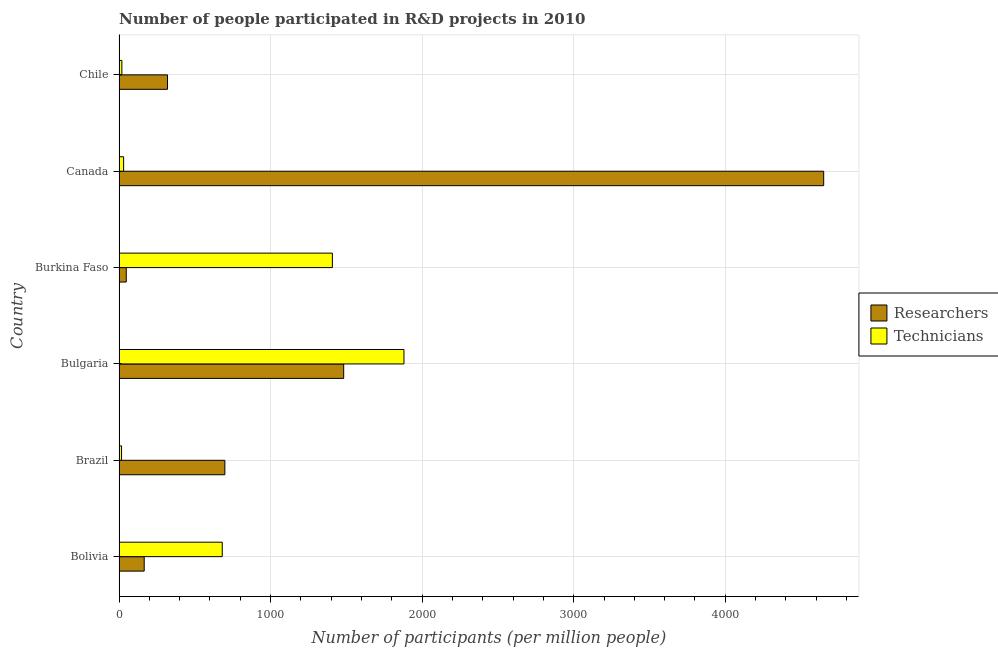How many different coloured bars are there?
Provide a succinct answer. 2. How many groups of bars are there?
Keep it short and to the point. 6. Are the number of bars on each tick of the Y-axis equal?
Offer a very short reply. Yes. How many bars are there on the 1st tick from the top?
Your answer should be compact. 2. How many bars are there on the 1st tick from the bottom?
Ensure brevity in your answer.  2. What is the label of the 4th group of bars from the top?
Provide a succinct answer. Bulgaria. In how many cases, is the number of bars for a given country not equal to the number of legend labels?
Your answer should be very brief. 0. What is the number of researchers in Chile?
Your answer should be compact. 319.72. Across all countries, what is the maximum number of researchers?
Give a very brief answer. 4649.22. Across all countries, what is the minimum number of technicians?
Ensure brevity in your answer.  16.46. In which country was the number of researchers minimum?
Keep it short and to the point. Burkina Faso. What is the total number of researchers in the graph?
Your answer should be very brief. 7362.67. What is the difference between the number of researchers in Bulgaria and that in Canada?
Provide a succinct answer. -3167.03. What is the difference between the number of technicians in Brazil and the number of researchers in Burkina Faso?
Provide a short and direct response. -31.04. What is the average number of researchers per country?
Provide a succinct answer. 1227.11. What is the difference between the number of researchers and number of technicians in Brazil?
Give a very brief answer. 681.64. In how many countries, is the number of researchers greater than 4000 ?
Offer a terse response. 1. What is the ratio of the number of technicians in Canada to that in Chile?
Offer a very short reply. 1.62. Is the number of technicians in Bolivia less than that in Brazil?
Keep it short and to the point. No. What is the difference between the highest and the second highest number of technicians?
Ensure brevity in your answer.  472.46. What is the difference between the highest and the lowest number of researchers?
Your answer should be very brief. 4601.72. In how many countries, is the number of technicians greater than the average number of technicians taken over all countries?
Ensure brevity in your answer.  3. Is the sum of the number of researchers in Brazil and Canada greater than the maximum number of technicians across all countries?
Your answer should be very brief. Yes. What does the 2nd bar from the top in Bulgaria represents?
Ensure brevity in your answer.  Researchers. What does the 1st bar from the bottom in Bulgaria represents?
Your answer should be very brief. Researchers. How many bars are there?
Keep it short and to the point. 12. How many countries are there in the graph?
Provide a short and direct response. 6. Where does the legend appear in the graph?
Provide a short and direct response. Center right. How are the legend labels stacked?
Keep it short and to the point. Vertical. What is the title of the graph?
Your answer should be compact. Number of people participated in R&D projects in 2010. What is the label or title of the X-axis?
Your answer should be very brief. Number of participants (per million people). What is the Number of participants (per million people) in Researchers in Bolivia?
Your answer should be very brief. 165.95. What is the Number of participants (per million people) in Technicians in Bolivia?
Your answer should be compact. 680.89. What is the Number of participants (per million people) in Researchers in Brazil?
Make the answer very short. 698.1. What is the Number of participants (per million people) in Technicians in Brazil?
Offer a terse response. 16.46. What is the Number of participants (per million people) of Researchers in Bulgaria?
Give a very brief answer. 1482.19. What is the Number of participants (per million people) of Technicians in Bulgaria?
Keep it short and to the point. 1879.95. What is the Number of participants (per million people) in Researchers in Burkina Faso?
Give a very brief answer. 47.49. What is the Number of participants (per million people) of Technicians in Burkina Faso?
Ensure brevity in your answer.  1407.48. What is the Number of participants (per million people) of Researchers in Canada?
Provide a succinct answer. 4649.22. What is the Number of participants (per million people) of Technicians in Canada?
Ensure brevity in your answer.  30.08. What is the Number of participants (per million people) of Researchers in Chile?
Your response must be concise. 319.72. What is the Number of participants (per million people) of Technicians in Chile?
Provide a short and direct response. 18.53. Across all countries, what is the maximum Number of participants (per million people) in Researchers?
Provide a short and direct response. 4649.22. Across all countries, what is the maximum Number of participants (per million people) in Technicians?
Your answer should be very brief. 1879.95. Across all countries, what is the minimum Number of participants (per million people) in Researchers?
Ensure brevity in your answer.  47.49. Across all countries, what is the minimum Number of participants (per million people) of Technicians?
Offer a very short reply. 16.46. What is the total Number of participants (per million people) of Researchers in the graph?
Provide a succinct answer. 7362.67. What is the total Number of participants (per million people) of Technicians in the graph?
Provide a succinct answer. 4033.38. What is the difference between the Number of participants (per million people) of Researchers in Bolivia and that in Brazil?
Keep it short and to the point. -532.15. What is the difference between the Number of participants (per million people) of Technicians in Bolivia and that in Brazil?
Keep it short and to the point. 664.43. What is the difference between the Number of participants (per million people) in Researchers in Bolivia and that in Bulgaria?
Offer a very short reply. -1316.23. What is the difference between the Number of participants (per million people) in Technicians in Bolivia and that in Bulgaria?
Provide a succinct answer. -1199.06. What is the difference between the Number of participants (per million people) in Researchers in Bolivia and that in Burkina Faso?
Your answer should be very brief. 118.46. What is the difference between the Number of participants (per million people) in Technicians in Bolivia and that in Burkina Faso?
Offer a terse response. -726.6. What is the difference between the Number of participants (per million people) in Researchers in Bolivia and that in Canada?
Your answer should be very brief. -4483.26. What is the difference between the Number of participants (per million people) of Technicians in Bolivia and that in Canada?
Your response must be concise. 650.81. What is the difference between the Number of participants (per million people) in Researchers in Bolivia and that in Chile?
Your answer should be compact. -153.76. What is the difference between the Number of participants (per million people) in Technicians in Bolivia and that in Chile?
Offer a terse response. 662.35. What is the difference between the Number of participants (per million people) in Researchers in Brazil and that in Bulgaria?
Offer a terse response. -784.09. What is the difference between the Number of participants (per million people) of Technicians in Brazil and that in Bulgaria?
Offer a terse response. -1863.49. What is the difference between the Number of participants (per million people) of Researchers in Brazil and that in Burkina Faso?
Offer a terse response. 650.61. What is the difference between the Number of participants (per million people) in Technicians in Brazil and that in Burkina Faso?
Ensure brevity in your answer.  -1391.03. What is the difference between the Number of participants (per million people) in Researchers in Brazil and that in Canada?
Your response must be concise. -3951.12. What is the difference between the Number of participants (per million people) of Technicians in Brazil and that in Canada?
Your answer should be very brief. -13.62. What is the difference between the Number of participants (per million people) of Researchers in Brazil and that in Chile?
Provide a short and direct response. 378.39. What is the difference between the Number of participants (per million people) in Technicians in Brazil and that in Chile?
Offer a terse response. -2.07. What is the difference between the Number of participants (per million people) of Researchers in Bulgaria and that in Burkina Faso?
Provide a short and direct response. 1434.69. What is the difference between the Number of participants (per million people) in Technicians in Bulgaria and that in Burkina Faso?
Ensure brevity in your answer.  472.46. What is the difference between the Number of participants (per million people) of Researchers in Bulgaria and that in Canada?
Offer a very short reply. -3167.03. What is the difference between the Number of participants (per million people) in Technicians in Bulgaria and that in Canada?
Your response must be concise. 1849.87. What is the difference between the Number of participants (per million people) in Researchers in Bulgaria and that in Chile?
Offer a terse response. 1162.47. What is the difference between the Number of participants (per million people) of Technicians in Bulgaria and that in Chile?
Ensure brevity in your answer.  1861.42. What is the difference between the Number of participants (per million people) in Researchers in Burkina Faso and that in Canada?
Your response must be concise. -4601.72. What is the difference between the Number of participants (per million people) in Technicians in Burkina Faso and that in Canada?
Provide a succinct answer. 1377.41. What is the difference between the Number of participants (per million people) of Researchers in Burkina Faso and that in Chile?
Offer a terse response. -272.22. What is the difference between the Number of participants (per million people) in Technicians in Burkina Faso and that in Chile?
Your answer should be very brief. 1388.95. What is the difference between the Number of participants (per million people) in Researchers in Canada and that in Chile?
Give a very brief answer. 4329.5. What is the difference between the Number of participants (per million people) of Technicians in Canada and that in Chile?
Ensure brevity in your answer.  11.55. What is the difference between the Number of participants (per million people) of Researchers in Bolivia and the Number of participants (per million people) of Technicians in Brazil?
Your answer should be very brief. 149.5. What is the difference between the Number of participants (per million people) of Researchers in Bolivia and the Number of participants (per million people) of Technicians in Bulgaria?
Offer a very short reply. -1713.99. What is the difference between the Number of participants (per million people) of Researchers in Bolivia and the Number of participants (per million people) of Technicians in Burkina Faso?
Provide a succinct answer. -1241.53. What is the difference between the Number of participants (per million people) of Researchers in Bolivia and the Number of participants (per million people) of Technicians in Canada?
Keep it short and to the point. 135.88. What is the difference between the Number of participants (per million people) of Researchers in Bolivia and the Number of participants (per million people) of Technicians in Chile?
Offer a terse response. 147.42. What is the difference between the Number of participants (per million people) in Researchers in Brazil and the Number of participants (per million people) in Technicians in Bulgaria?
Your answer should be very brief. -1181.84. What is the difference between the Number of participants (per million people) of Researchers in Brazil and the Number of participants (per million people) of Technicians in Burkina Faso?
Offer a terse response. -709.38. What is the difference between the Number of participants (per million people) in Researchers in Brazil and the Number of participants (per million people) in Technicians in Canada?
Keep it short and to the point. 668.03. What is the difference between the Number of participants (per million people) in Researchers in Brazil and the Number of participants (per million people) in Technicians in Chile?
Ensure brevity in your answer.  679.57. What is the difference between the Number of participants (per million people) in Researchers in Bulgaria and the Number of participants (per million people) in Technicians in Burkina Faso?
Provide a succinct answer. 74.7. What is the difference between the Number of participants (per million people) in Researchers in Bulgaria and the Number of participants (per million people) in Technicians in Canada?
Provide a short and direct response. 1452.11. What is the difference between the Number of participants (per million people) in Researchers in Bulgaria and the Number of participants (per million people) in Technicians in Chile?
Offer a terse response. 1463.66. What is the difference between the Number of participants (per million people) of Researchers in Burkina Faso and the Number of participants (per million people) of Technicians in Canada?
Provide a short and direct response. 17.42. What is the difference between the Number of participants (per million people) in Researchers in Burkina Faso and the Number of participants (per million people) in Technicians in Chile?
Ensure brevity in your answer.  28.96. What is the difference between the Number of participants (per million people) in Researchers in Canada and the Number of participants (per million people) in Technicians in Chile?
Your answer should be very brief. 4630.69. What is the average Number of participants (per million people) of Researchers per country?
Make the answer very short. 1227.11. What is the average Number of participants (per million people) in Technicians per country?
Your answer should be very brief. 672.23. What is the difference between the Number of participants (per million people) of Researchers and Number of participants (per million people) of Technicians in Bolivia?
Your answer should be compact. -514.93. What is the difference between the Number of participants (per million people) of Researchers and Number of participants (per million people) of Technicians in Brazil?
Provide a succinct answer. 681.65. What is the difference between the Number of participants (per million people) in Researchers and Number of participants (per million people) in Technicians in Bulgaria?
Your answer should be very brief. -397.76. What is the difference between the Number of participants (per million people) in Researchers and Number of participants (per million people) in Technicians in Burkina Faso?
Offer a very short reply. -1359.99. What is the difference between the Number of participants (per million people) in Researchers and Number of participants (per million people) in Technicians in Canada?
Your answer should be compact. 4619.14. What is the difference between the Number of participants (per million people) in Researchers and Number of participants (per million people) in Technicians in Chile?
Keep it short and to the point. 301.19. What is the ratio of the Number of participants (per million people) of Researchers in Bolivia to that in Brazil?
Provide a succinct answer. 0.24. What is the ratio of the Number of participants (per million people) of Technicians in Bolivia to that in Brazil?
Offer a very short reply. 41.37. What is the ratio of the Number of participants (per million people) in Researchers in Bolivia to that in Bulgaria?
Provide a succinct answer. 0.11. What is the ratio of the Number of participants (per million people) of Technicians in Bolivia to that in Bulgaria?
Make the answer very short. 0.36. What is the ratio of the Number of participants (per million people) in Researchers in Bolivia to that in Burkina Faso?
Give a very brief answer. 3.49. What is the ratio of the Number of participants (per million people) of Technicians in Bolivia to that in Burkina Faso?
Provide a succinct answer. 0.48. What is the ratio of the Number of participants (per million people) in Researchers in Bolivia to that in Canada?
Your answer should be very brief. 0.04. What is the ratio of the Number of participants (per million people) in Technicians in Bolivia to that in Canada?
Give a very brief answer. 22.64. What is the ratio of the Number of participants (per million people) of Researchers in Bolivia to that in Chile?
Your answer should be compact. 0.52. What is the ratio of the Number of participants (per million people) in Technicians in Bolivia to that in Chile?
Make the answer very short. 36.74. What is the ratio of the Number of participants (per million people) of Researchers in Brazil to that in Bulgaria?
Offer a very short reply. 0.47. What is the ratio of the Number of participants (per million people) in Technicians in Brazil to that in Bulgaria?
Your response must be concise. 0.01. What is the ratio of the Number of participants (per million people) of Researchers in Brazil to that in Burkina Faso?
Make the answer very short. 14.7. What is the ratio of the Number of participants (per million people) of Technicians in Brazil to that in Burkina Faso?
Your response must be concise. 0.01. What is the ratio of the Number of participants (per million people) of Researchers in Brazil to that in Canada?
Offer a very short reply. 0.15. What is the ratio of the Number of participants (per million people) of Technicians in Brazil to that in Canada?
Provide a succinct answer. 0.55. What is the ratio of the Number of participants (per million people) of Researchers in Brazil to that in Chile?
Offer a terse response. 2.18. What is the ratio of the Number of participants (per million people) of Technicians in Brazil to that in Chile?
Make the answer very short. 0.89. What is the ratio of the Number of participants (per million people) in Researchers in Bulgaria to that in Burkina Faso?
Your answer should be very brief. 31.21. What is the ratio of the Number of participants (per million people) in Technicians in Bulgaria to that in Burkina Faso?
Your answer should be very brief. 1.34. What is the ratio of the Number of participants (per million people) of Researchers in Bulgaria to that in Canada?
Your answer should be very brief. 0.32. What is the ratio of the Number of participants (per million people) in Technicians in Bulgaria to that in Canada?
Offer a terse response. 62.5. What is the ratio of the Number of participants (per million people) of Researchers in Bulgaria to that in Chile?
Keep it short and to the point. 4.64. What is the ratio of the Number of participants (per million people) in Technicians in Bulgaria to that in Chile?
Your answer should be very brief. 101.45. What is the ratio of the Number of participants (per million people) in Researchers in Burkina Faso to that in Canada?
Keep it short and to the point. 0.01. What is the ratio of the Number of participants (per million people) in Technicians in Burkina Faso to that in Canada?
Give a very brief answer. 46.8. What is the ratio of the Number of participants (per million people) of Researchers in Burkina Faso to that in Chile?
Provide a short and direct response. 0.15. What is the ratio of the Number of participants (per million people) in Technicians in Burkina Faso to that in Chile?
Offer a very short reply. 75.95. What is the ratio of the Number of participants (per million people) of Researchers in Canada to that in Chile?
Your response must be concise. 14.54. What is the ratio of the Number of participants (per million people) of Technicians in Canada to that in Chile?
Make the answer very short. 1.62. What is the difference between the highest and the second highest Number of participants (per million people) in Researchers?
Your answer should be compact. 3167.03. What is the difference between the highest and the second highest Number of participants (per million people) in Technicians?
Make the answer very short. 472.46. What is the difference between the highest and the lowest Number of participants (per million people) of Researchers?
Your answer should be compact. 4601.72. What is the difference between the highest and the lowest Number of participants (per million people) of Technicians?
Give a very brief answer. 1863.49. 